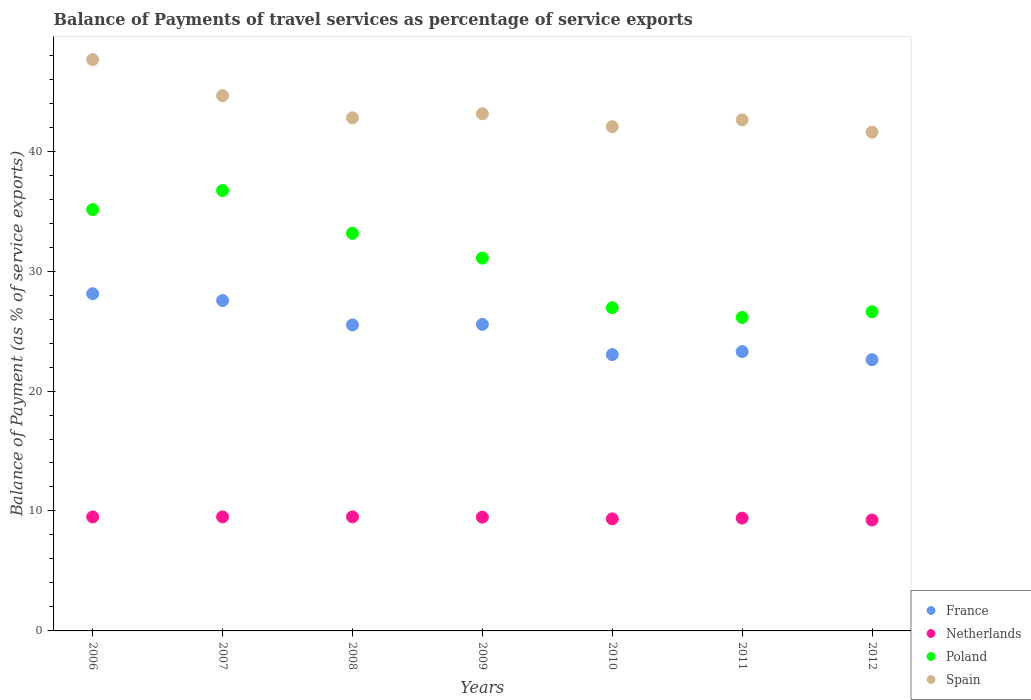How many different coloured dotlines are there?
Keep it short and to the point. 4. Is the number of dotlines equal to the number of legend labels?
Offer a terse response. Yes. What is the balance of payments of travel services in Poland in 2008?
Keep it short and to the point. 33.15. Across all years, what is the maximum balance of payments of travel services in Spain?
Offer a very short reply. 47.63. Across all years, what is the minimum balance of payments of travel services in Spain?
Give a very brief answer. 41.58. In which year was the balance of payments of travel services in Netherlands minimum?
Keep it short and to the point. 2012. What is the total balance of payments of travel services in France in the graph?
Provide a short and direct response. 175.66. What is the difference between the balance of payments of travel services in France in 2009 and that in 2012?
Your answer should be compact. 2.94. What is the difference between the balance of payments of travel services in Poland in 2011 and the balance of payments of travel services in Spain in 2007?
Offer a very short reply. -18.49. What is the average balance of payments of travel services in France per year?
Offer a very short reply. 25.09. In the year 2007, what is the difference between the balance of payments of travel services in Poland and balance of payments of travel services in Netherlands?
Your response must be concise. 27.21. In how many years, is the balance of payments of travel services in Spain greater than 28 %?
Keep it short and to the point. 7. What is the ratio of the balance of payments of travel services in Spain in 2009 to that in 2012?
Provide a short and direct response. 1.04. Is the balance of payments of travel services in France in 2009 less than that in 2012?
Make the answer very short. No. What is the difference between the highest and the second highest balance of payments of travel services in Spain?
Give a very brief answer. 3.01. What is the difference between the highest and the lowest balance of payments of travel services in France?
Your response must be concise. 5.5. Is it the case that in every year, the sum of the balance of payments of travel services in Poland and balance of payments of travel services in Spain  is greater than the balance of payments of travel services in France?
Provide a succinct answer. Yes. How many years are there in the graph?
Make the answer very short. 7. Are the values on the major ticks of Y-axis written in scientific E-notation?
Provide a short and direct response. No. How many legend labels are there?
Your response must be concise. 4. How are the legend labels stacked?
Keep it short and to the point. Vertical. What is the title of the graph?
Offer a terse response. Balance of Payments of travel services as percentage of service exports. Does "Channel Islands" appear as one of the legend labels in the graph?
Provide a short and direct response. No. What is the label or title of the X-axis?
Offer a very short reply. Years. What is the label or title of the Y-axis?
Make the answer very short. Balance of Payment (as % of service exports). What is the Balance of Payment (as % of service exports) in France in 2006?
Provide a succinct answer. 28.11. What is the Balance of Payment (as % of service exports) in Netherlands in 2006?
Ensure brevity in your answer.  9.5. What is the Balance of Payment (as % of service exports) of Poland in 2006?
Your answer should be compact. 35.13. What is the Balance of Payment (as % of service exports) of Spain in 2006?
Your answer should be very brief. 47.63. What is the Balance of Payment (as % of service exports) of France in 2007?
Offer a very short reply. 27.54. What is the Balance of Payment (as % of service exports) of Netherlands in 2007?
Ensure brevity in your answer.  9.51. What is the Balance of Payment (as % of service exports) of Poland in 2007?
Provide a succinct answer. 36.72. What is the Balance of Payment (as % of service exports) in Spain in 2007?
Provide a succinct answer. 44.62. What is the Balance of Payment (as % of service exports) of France in 2008?
Your response must be concise. 25.51. What is the Balance of Payment (as % of service exports) of Netherlands in 2008?
Your response must be concise. 9.51. What is the Balance of Payment (as % of service exports) of Poland in 2008?
Provide a short and direct response. 33.15. What is the Balance of Payment (as % of service exports) of Spain in 2008?
Ensure brevity in your answer.  42.78. What is the Balance of Payment (as % of service exports) of France in 2009?
Provide a short and direct response. 25.55. What is the Balance of Payment (as % of service exports) of Netherlands in 2009?
Give a very brief answer. 9.49. What is the Balance of Payment (as % of service exports) in Poland in 2009?
Offer a very short reply. 31.08. What is the Balance of Payment (as % of service exports) in Spain in 2009?
Your response must be concise. 43.11. What is the Balance of Payment (as % of service exports) in France in 2010?
Your response must be concise. 23.04. What is the Balance of Payment (as % of service exports) of Netherlands in 2010?
Offer a terse response. 9.34. What is the Balance of Payment (as % of service exports) in Poland in 2010?
Keep it short and to the point. 26.95. What is the Balance of Payment (as % of service exports) of Spain in 2010?
Your answer should be very brief. 42.04. What is the Balance of Payment (as % of service exports) of France in 2011?
Provide a succinct answer. 23.29. What is the Balance of Payment (as % of service exports) of Netherlands in 2011?
Provide a succinct answer. 9.41. What is the Balance of Payment (as % of service exports) in Poland in 2011?
Your answer should be compact. 26.13. What is the Balance of Payment (as % of service exports) of Spain in 2011?
Offer a terse response. 42.6. What is the Balance of Payment (as % of service exports) of France in 2012?
Provide a succinct answer. 22.61. What is the Balance of Payment (as % of service exports) in Netherlands in 2012?
Your answer should be very brief. 9.25. What is the Balance of Payment (as % of service exports) of Poland in 2012?
Provide a succinct answer. 26.6. What is the Balance of Payment (as % of service exports) of Spain in 2012?
Ensure brevity in your answer.  41.58. Across all years, what is the maximum Balance of Payment (as % of service exports) in France?
Your response must be concise. 28.11. Across all years, what is the maximum Balance of Payment (as % of service exports) in Netherlands?
Keep it short and to the point. 9.51. Across all years, what is the maximum Balance of Payment (as % of service exports) in Poland?
Give a very brief answer. 36.72. Across all years, what is the maximum Balance of Payment (as % of service exports) in Spain?
Provide a succinct answer. 47.63. Across all years, what is the minimum Balance of Payment (as % of service exports) of France?
Make the answer very short. 22.61. Across all years, what is the minimum Balance of Payment (as % of service exports) in Netherlands?
Provide a short and direct response. 9.25. Across all years, what is the minimum Balance of Payment (as % of service exports) in Poland?
Give a very brief answer. 26.13. Across all years, what is the minimum Balance of Payment (as % of service exports) in Spain?
Make the answer very short. 41.58. What is the total Balance of Payment (as % of service exports) in France in the graph?
Provide a succinct answer. 175.66. What is the total Balance of Payment (as % of service exports) of Netherlands in the graph?
Keep it short and to the point. 65.99. What is the total Balance of Payment (as % of service exports) of Poland in the graph?
Keep it short and to the point. 215.76. What is the total Balance of Payment (as % of service exports) of Spain in the graph?
Your answer should be very brief. 304.36. What is the difference between the Balance of Payment (as % of service exports) in France in 2006 and that in 2007?
Give a very brief answer. 0.57. What is the difference between the Balance of Payment (as % of service exports) in Netherlands in 2006 and that in 2007?
Your response must be concise. -0.01. What is the difference between the Balance of Payment (as % of service exports) of Poland in 2006 and that in 2007?
Your answer should be compact. -1.59. What is the difference between the Balance of Payment (as % of service exports) of Spain in 2006 and that in 2007?
Make the answer very short. 3.01. What is the difference between the Balance of Payment (as % of service exports) in France in 2006 and that in 2008?
Your answer should be compact. 2.6. What is the difference between the Balance of Payment (as % of service exports) of Netherlands in 2006 and that in 2008?
Keep it short and to the point. -0.01. What is the difference between the Balance of Payment (as % of service exports) in Poland in 2006 and that in 2008?
Provide a succinct answer. 1.98. What is the difference between the Balance of Payment (as % of service exports) of Spain in 2006 and that in 2008?
Make the answer very short. 4.86. What is the difference between the Balance of Payment (as % of service exports) of France in 2006 and that in 2009?
Provide a succinct answer. 2.56. What is the difference between the Balance of Payment (as % of service exports) in Netherlands in 2006 and that in 2009?
Offer a very short reply. 0.01. What is the difference between the Balance of Payment (as % of service exports) of Poland in 2006 and that in 2009?
Give a very brief answer. 4.04. What is the difference between the Balance of Payment (as % of service exports) of Spain in 2006 and that in 2009?
Ensure brevity in your answer.  4.52. What is the difference between the Balance of Payment (as % of service exports) of France in 2006 and that in 2010?
Your response must be concise. 5.07. What is the difference between the Balance of Payment (as % of service exports) in Netherlands in 2006 and that in 2010?
Your response must be concise. 0.16. What is the difference between the Balance of Payment (as % of service exports) of Poland in 2006 and that in 2010?
Give a very brief answer. 8.18. What is the difference between the Balance of Payment (as % of service exports) of Spain in 2006 and that in 2010?
Provide a short and direct response. 5.59. What is the difference between the Balance of Payment (as % of service exports) of France in 2006 and that in 2011?
Provide a succinct answer. 4.82. What is the difference between the Balance of Payment (as % of service exports) in Netherlands in 2006 and that in 2011?
Your answer should be very brief. 0.09. What is the difference between the Balance of Payment (as % of service exports) of Poland in 2006 and that in 2011?
Ensure brevity in your answer.  8.99. What is the difference between the Balance of Payment (as % of service exports) in Spain in 2006 and that in 2011?
Give a very brief answer. 5.03. What is the difference between the Balance of Payment (as % of service exports) in France in 2006 and that in 2012?
Your response must be concise. 5.5. What is the difference between the Balance of Payment (as % of service exports) in Netherlands in 2006 and that in 2012?
Provide a short and direct response. 0.25. What is the difference between the Balance of Payment (as % of service exports) of Poland in 2006 and that in 2012?
Give a very brief answer. 8.52. What is the difference between the Balance of Payment (as % of service exports) of Spain in 2006 and that in 2012?
Keep it short and to the point. 6.05. What is the difference between the Balance of Payment (as % of service exports) of France in 2007 and that in 2008?
Offer a very short reply. 2.03. What is the difference between the Balance of Payment (as % of service exports) in Netherlands in 2007 and that in 2008?
Give a very brief answer. -0. What is the difference between the Balance of Payment (as % of service exports) in Poland in 2007 and that in 2008?
Provide a short and direct response. 3.57. What is the difference between the Balance of Payment (as % of service exports) in Spain in 2007 and that in 2008?
Give a very brief answer. 1.85. What is the difference between the Balance of Payment (as % of service exports) in France in 2007 and that in 2009?
Give a very brief answer. 1.99. What is the difference between the Balance of Payment (as % of service exports) in Netherlands in 2007 and that in 2009?
Provide a short and direct response. 0.02. What is the difference between the Balance of Payment (as % of service exports) of Poland in 2007 and that in 2009?
Your answer should be compact. 5.63. What is the difference between the Balance of Payment (as % of service exports) of Spain in 2007 and that in 2009?
Ensure brevity in your answer.  1.51. What is the difference between the Balance of Payment (as % of service exports) of France in 2007 and that in 2010?
Keep it short and to the point. 4.51. What is the difference between the Balance of Payment (as % of service exports) of Netherlands in 2007 and that in 2010?
Ensure brevity in your answer.  0.17. What is the difference between the Balance of Payment (as % of service exports) of Poland in 2007 and that in 2010?
Keep it short and to the point. 9.77. What is the difference between the Balance of Payment (as % of service exports) in Spain in 2007 and that in 2010?
Your answer should be compact. 2.59. What is the difference between the Balance of Payment (as % of service exports) of France in 2007 and that in 2011?
Provide a short and direct response. 4.26. What is the difference between the Balance of Payment (as % of service exports) in Netherlands in 2007 and that in 2011?
Your response must be concise. 0.1. What is the difference between the Balance of Payment (as % of service exports) of Poland in 2007 and that in 2011?
Offer a terse response. 10.58. What is the difference between the Balance of Payment (as % of service exports) of Spain in 2007 and that in 2011?
Keep it short and to the point. 2.02. What is the difference between the Balance of Payment (as % of service exports) in France in 2007 and that in 2012?
Keep it short and to the point. 4.93. What is the difference between the Balance of Payment (as % of service exports) in Netherlands in 2007 and that in 2012?
Your response must be concise. 0.26. What is the difference between the Balance of Payment (as % of service exports) in Poland in 2007 and that in 2012?
Provide a short and direct response. 10.11. What is the difference between the Balance of Payment (as % of service exports) of Spain in 2007 and that in 2012?
Make the answer very short. 3.04. What is the difference between the Balance of Payment (as % of service exports) in France in 2008 and that in 2009?
Your answer should be compact. -0.04. What is the difference between the Balance of Payment (as % of service exports) in Netherlands in 2008 and that in 2009?
Ensure brevity in your answer.  0.02. What is the difference between the Balance of Payment (as % of service exports) of Poland in 2008 and that in 2009?
Your answer should be compact. 2.07. What is the difference between the Balance of Payment (as % of service exports) of Spain in 2008 and that in 2009?
Your answer should be compact. -0.34. What is the difference between the Balance of Payment (as % of service exports) of France in 2008 and that in 2010?
Your response must be concise. 2.48. What is the difference between the Balance of Payment (as % of service exports) of Netherlands in 2008 and that in 2010?
Your response must be concise. 0.17. What is the difference between the Balance of Payment (as % of service exports) in Poland in 2008 and that in 2010?
Keep it short and to the point. 6.2. What is the difference between the Balance of Payment (as % of service exports) of Spain in 2008 and that in 2010?
Offer a terse response. 0.74. What is the difference between the Balance of Payment (as % of service exports) in France in 2008 and that in 2011?
Offer a terse response. 2.23. What is the difference between the Balance of Payment (as % of service exports) in Netherlands in 2008 and that in 2011?
Offer a terse response. 0.1. What is the difference between the Balance of Payment (as % of service exports) in Poland in 2008 and that in 2011?
Your response must be concise. 7.01. What is the difference between the Balance of Payment (as % of service exports) of Spain in 2008 and that in 2011?
Provide a succinct answer. 0.17. What is the difference between the Balance of Payment (as % of service exports) of France in 2008 and that in 2012?
Give a very brief answer. 2.9. What is the difference between the Balance of Payment (as % of service exports) in Netherlands in 2008 and that in 2012?
Provide a succinct answer. 0.26. What is the difference between the Balance of Payment (as % of service exports) of Poland in 2008 and that in 2012?
Provide a short and direct response. 6.54. What is the difference between the Balance of Payment (as % of service exports) of Spain in 2008 and that in 2012?
Ensure brevity in your answer.  1.2. What is the difference between the Balance of Payment (as % of service exports) of France in 2009 and that in 2010?
Give a very brief answer. 2.52. What is the difference between the Balance of Payment (as % of service exports) of Netherlands in 2009 and that in 2010?
Keep it short and to the point. 0.14. What is the difference between the Balance of Payment (as % of service exports) in Poland in 2009 and that in 2010?
Make the answer very short. 4.14. What is the difference between the Balance of Payment (as % of service exports) of Spain in 2009 and that in 2010?
Your answer should be very brief. 1.08. What is the difference between the Balance of Payment (as % of service exports) in France in 2009 and that in 2011?
Your answer should be compact. 2.27. What is the difference between the Balance of Payment (as % of service exports) in Netherlands in 2009 and that in 2011?
Keep it short and to the point. 0.08. What is the difference between the Balance of Payment (as % of service exports) in Poland in 2009 and that in 2011?
Ensure brevity in your answer.  4.95. What is the difference between the Balance of Payment (as % of service exports) in Spain in 2009 and that in 2011?
Make the answer very short. 0.51. What is the difference between the Balance of Payment (as % of service exports) in France in 2009 and that in 2012?
Offer a terse response. 2.94. What is the difference between the Balance of Payment (as % of service exports) in Netherlands in 2009 and that in 2012?
Your answer should be very brief. 0.24. What is the difference between the Balance of Payment (as % of service exports) in Poland in 2009 and that in 2012?
Give a very brief answer. 4.48. What is the difference between the Balance of Payment (as % of service exports) of Spain in 2009 and that in 2012?
Ensure brevity in your answer.  1.53. What is the difference between the Balance of Payment (as % of service exports) in Netherlands in 2010 and that in 2011?
Ensure brevity in your answer.  -0.06. What is the difference between the Balance of Payment (as % of service exports) in Poland in 2010 and that in 2011?
Ensure brevity in your answer.  0.81. What is the difference between the Balance of Payment (as % of service exports) of Spain in 2010 and that in 2011?
Your response must be concise. -0.57. What is the difference between the Balance of Payment (as % of service exports) of France in 2010 and that in 2012?
Provide a succinct answer. 0.42. What is the difference between the Balance of Payment (as % of service exports) in Netherlands in 2010 and that in 2012?
Offer a terse response. 0.1. What is the difference between the Balance of Payment (as % of service exports) of Poland in 2010 and that in 2012?
Keep it short and to the point. 0.34. What is the difference between the Balance of Payment (as % of service exports) of Spain in 2010 and that in 2012?
Your answer should be compact. 0.46. What is the difference between the Balance of Payment (as % of service exports) of France in 2011 and that in 2012?
Your response must be concise. 0.67. What is the difference between the Balance of Payment (as % of service exports) of Netherlands in 2011 and that in 2012?
Your answer should be very brief. 0.16. What is the difference between the Balance of Payment (as % of service exports) in Poland in 2011 and that in 2012?
Make the answer very short. -0.47. What is the difference between the Balance of Payment (as % of service exports) of Spain in 2011 and that in 2012?
Your answer should be very brief. 1.02. What is the difference between the Balance of Payment (as % of service exports) in France in 2006 and the Balance of Payment (as % of service exports) in Netherlands in 2007?
Offer a very short reply. 18.6. What is the difference between the Balance of Payment (as % of service exports) in France in 2006 and the Balance of Payment (as % of service exports) in Poland in 2007?
Ensure brevity in your answer.  -8.6. What is the difference between the Balance of Payment (as % of service exports) of France in 2006 and the Balance of Payment (as % of service exports) of Spain in 2007?
Give a very brief answer. -16.51. What is the difference between the Balance of Payment (as % of service exports) of Netherlands in 2006 and the Balance of Payment (as % of service exports) of Poland in 2007?
Offer a terse response. -27.22. What is the difference between the Balance of Payment (as % of service exports) in Netherlands in 2006 and the Balance of Payment (as % of service exports) in Spain in 2007?
Your answer should be very brief. -35.12. What is the difference between the Balance of Payment (as % of service exports) in Poland in 2006 and the Balance of Payment (as % of service exports) in Spain in 2007?
Make the answer very short. -9.5. What is the difference between the Balance of Payment (as % of service exports) in France in 2006 and the Balance of Payment (as % of service exports) in Netherlands in 2008?
Provide a short and direct response. 18.6. What is the difference between the Balance of Payment (as % of service exports) of France in 2006 and the Balance of Payment (as % of service exports) of Poland in 2008?
Your answer should be compact. -5.04. What is the difference between the Balance of Payment (as % of service exports) of France in 2006 and the Balance of Payment (as % of service exports) of Spain in 2008?
Your answer should be compact. -14.66. What is the difference between the Balance of Payment (as % of service exports) of Netherlands in 2006 and the Balance of Payment (as % of service exports) of Poland in 2008?
Your answer should be compact. -23.65. What is the difference between the Balance of Payment (as % of service exports) of Netherlands in 2006 and the Balance of Payment (as % of service exports) of Spain in 2008?
Ensure brevity in your answer.  -33.28. What is the difference between the Balance of Payment (as % of service exports) of Poland in 2006 and the Balance of Payment (as % of service exports) of Spain in 2008?
Make the answer very short. -7.65. What is the difference between the Balance of Payment (as % of service exports) of France in 2006 and the Balance of Payment (as % of service exports) of Netherlands in 2009?
Offer a terse response. 18.63. What is the difference between the Balance of Payment (as % of service exports) of France in 2006 and the Balance of Payment (as % of service exports) of Poland in 2009?
Offer a very short reply. -2.97. What is the difference between the Balance of Payment (as % of service exports) in France in 2006 and the Balance of Payment (as % of service exports) in Spain in 2009?
Ensure brevity in your answer.  -15. What is the difference between the Balance of Payment (as % of service exports) in Netherlands in 2006 and the Balance of Payment (as % of service exports) in Poland in 2009?
Your answer should be very brief. -21.58. What is the difference between the Balance of Payment (as % of service exports) in Netherlands in 2006 and the Balance of Payment (as % of service exports) in Spain in 2009?
Your response must be concise. -33.61. What is the difference between the Balance of Payment (as % of service exports) of Poland in 2006 and the Balance of Payment (as % of service exports) of Spain in 2009?
Keep it short and to the point. -7.99. What is the difference between the Balance of Payment (as % of service exports) in France in 2006 and the Balance of Payment (as % of service exports) in Netherlands in 2010?
Keep it short and to the point. 18.77. What is the difference between the Balance of Payment (as % of service exports) in France in 2006 and the Balance of Payment (as % of service exports) in Poland in 2010?
Provide a short and direct response. 1.17. What is the difference between the Balance of Payment (as % of service exports) of France in 2006 and the Balance of Payment (as % of service exports) of Spain in 2010?
Provide a short and direct response. -13.93. What is the difference between the Balance of Payment (as % of service exports) of Netherlands in 2006 and the Balance of Payment (as % of service exports) of Poland in 2010?
Keep it short and to the point. -17.45. What is the difference between the Balance of Payment (as % of service exports) of Netherlands in 2006 and the Balance of Payment (as % of service exports) of Spain in 2010?
Provide a succinct answer. -32.54. What is the difference between the Balance of Payment (as % of service exports) of Poland in 2006 and the Balance of Payment (as % of service exports) of Spain in 2010?
Offer a terse response. -6.91. What is the difference between the Balance of Payment (as % of service exports) of France in 2006 and the Balance of Payment (as % of service exports) of Netherlands in 2011?
Your response must be concise. 18.71. What is the difference between the Balance of Payment (as % of service exports) of France in 2006 and the Balance of Payment (as % of service exports) of Poland in 2011?
Make the answer very short. 1.98. What is the difference between the Balance of Payment (as % of service exports) in France in 2006 and the Balance of Payment (as % of service exports) in Spain in 2011?
Offer a terse response. -14.49. What is the difference between the Balance of Payment (as % of service exports) of Netherlands in 2006 and the Balance of Payment (as % of service exports) of Poland in 2011?
Your answer should be very brief. -16.63. What is the difference between the Balance of Payment (as % of service exports) of Netherlands in 2006 and the Balance of Payment (as % of service exports) of Spain in 2011?
Your answer should be compact. -33.1. What is the difference between the Balance of Payment (as % of service exports) of Poland in 2006 and the Balance of Payment (as % of service exports) of Spain in 2011?
Make the answer very short. -7.48. What is the difference between the Balance of Payment (as % of service exports) of France in 2006 and the Balance of Payment (as % of service exports) of Netherlands in 2012?
Your answer should be compact. 18.86. What is the difference between the Balance of Payment (as % of service exports) in France in 2006 and the Balance of Payment (as % of service exports) in Poland in 2012?
Ensure brevity in your answer.  1.51. What is the difference between the Balance of Payment (as % of service exports) in France in 2006 and the Balance of Payment (as % of service exports) in Spain in 2012?
Offer a terse response. -13.47. What is the difference between the Balance of Payment (as % of service exports) of Netherlands in 2006 and the Balance of Payment (as % of service exports) of Poland in 2012?
Keep it short and to the point. -17.1. What is the difference between the Balance of Payment (as % of service exports) of Netherlands in 2006 and the Balance of Payment (as % of service exports) of Spain in 2012?
Your response must be concise. -32.08. What is the difference between the Balance of Payment (as % of service exports) in Poland in 2006 and the Balance of Payment (as % of service exports) in Spain in 2012?
Give a very brief answer. -6.46. What is the difference between the Balance of Payment (as % of service exports) in France in 2007 and the Balance of Payment (as % of service exports) in Netherlands in 2008?
Ensure brevity in your answer.  18.03. What is the difference between the Balance of Payment (as % of service exports) of France in 2007 and the Balance of Payment (as % of service exports) of Poland in 2008?
Your answer should be very brief. -5.61. What is the difference between the Balance of Payment (as % of service exports) in France in 2007 and the Balance of Payment (as % of service exports) in Spain in 2008?
Ensure brevity in your answer.  -15.23. What is the difference between the Balance of Payment (as % of service exports) in Netherlands in 2007 and the Balance of Payment (as % of service exports) in Poland in 2008?
Provide a succinct answer. -23.64. What is the difference between the Balance of Payment (as % of service exports) of Netherlands in 2007 and the Balance of Payment (as % of service exports) of Spain in 2008?
Your answer should be very brief. -33.27. What is the difference between the Balance of Payment (as % of service exports) of Poland in 2007 and the Balance of Payment (as % of service exports) of Spain in 2008?
Provide a succinct answer. -6.06. What is the difference between the Balance of Payment (as % of service exports) of France in 2007 and the Balance of Payment (as % of service exports) of Netherlands in 2009?
Offer a very short reply. 18.06. What is the difference between the Balance of Payment (as % of service exports) of France in 2007 and the Balance of Payment (as % of service exports) of Poland in 2009?
Offer a very short reply. -3.54. What is the difference between the Balance of Payment (as % of service exports) of France in 2007 and the Balance of Payment (as % of service exports) of Spain in 2009?
Your answer should be very brief. -15.57. What is the difference between the Balance of Payment (as % of service exports) in Netherlands in 2007 and the Balance of Payment (as % of service exports) in Poland in 2009?
Your answer should be very brief. -21.58. What is the difference between the Balance of Payment (as % of service exports) in Netherlands in 2007 and the Balance of Payment (as % of service exports) in Spain in 2009?
Offer a very short reply. -33.61. What is the difference between the Balance of Payment (as % of service exports) in Poland in 2007 and the Balance of Payment (as % of service exports) in Spain in 2009?
Offer a very short reply. -6.4. What is the difference between the Balance of Payment (as % of service exports) of France in 2007 and the Balance of Payment (as % of service exports) of Netherlands in 2010?
Your response must be concise. 18.2. What is the difference between the Balance of Payment (as % of service exports) of France in 2007 and the Balance of Payment (as % of service exports) of Poland in 2010?
Provide a short and direct response. 0.6. What is the difference between the Balance of Payment (as % of service exports) in France in 2007 and the Balance of Payment (as % of service exports) in Spain in 2010?
Provide a succinct answer. -14.49. What is the difference between the Balance of Payment (as % of service exports) of Netherlands in 2007 and the Balance of Payment (as % of service exports) of Poland in 2010?
Keep it short and to the point. -17.44. What is the difference between the Balance of Payment (as % of service exports) of Netherlands in 2007 and the Balance of Payment (as % of service exports) of Spain in 2010?
Make the answer very short. -32.53. What is the difference between the Balance of Payment (as % of service exports) of Poland in 2007 and the Balance of Payment (as % of service exports) of Spain in 2010?
Provide a succinct answer. -5.32. What is the difference between the Balance of Payment (as % of service exports) of France in 2007 and the Balance of Payment (as % of service exports) of Netherlands in 2011?
Keep it short and to the point. 18.14. What is the difference between the Balance of Payment (as % of service exports) in France in 2007 and the Balance of Payment (as % of service exports) in Poland in 2011?
Offer a terse response. 1.41. What is the difference between the Balance of Payment (as % of service exports) in France in 2007 and the Balance of Payment (as % of service exports) in Spain in 2011?
Make the answer very short. -15.06. What is the difference between the Balance of Payment (as % of service exports) in Netherlands in 2007 and the Balance of Payment (as % of service exports) in Poland in 2011?
Provide a succinct answer. -16.63. What is the difference between the Balance of Payment (as % of service exports) in Netherlands in 2007 and the Balance of Payment (as % of service exports) in Spain in 2011?
Offer a very short reply. -33.1. What is the difference between the Balance of Payment (as % of service exports) of Poland in 2007 and the Balance of Payment (as % of service exports) of Spain in 2011?
Your answer should be compact. -5.89. What is the difference between the Balance of Payment (as % of service exports) of France in 2007 and the Balance of Payment (as % of service exports) of Netherlands in 2012?
Keep it short and to the point. 18.3. What is the difference between the Balance of Payment (as % of service exports) in France in 2007 and the Balance of Payment (as % of service exports) in Poland in 2012?
Give a very brief answer. 0.94. What is the difference between the Balance of Payment (as % of service exports) of France in 2007 and the Balance of Payment (as % of service exports) of Spain in 2012?
Provide a short and direct response. -14.04. What is the difference between the Balance of Payment (as % of service exports) in Netherlands in 2007 and the Balance of Payment (as % of service exports) in Poland in 2012?
Make the answer very short. -17.1. What is the difference between the Balance of Payment (as % of service exports) in Netherlands in 2007 and the Balance of Payment (as % of service exports) in Spain in 2012?
Your answer should be very brief. -32.07. What is the difference between the Balance of Payment (as % of service exports) in Poland in 2007 and the Balance of Payment (as % of service exports) in Spain in 2012?
Offer a terse response. -4.87. What is the difference between the Balance of Payment (as % of service exports) of France in 2008 and the Balance of Payment (as % of service exports) of Netherlands in 2009?
Offer a very short reply. 16.03. What is the difference between the Balance of Payment (as % of service exports) of France in 2008 and the Balance of Payment (as % of service exports) of Poland in 2009?
Your answer should be compact. -5.57. What is the difference between the Balance of Payment (as % of service exports) of France in 2008 and the Balance of Payment (as % of service exports) of Spain in 2009?
Offer a terse response. -17.6. What is the difference between the Balance of Payment (as % of service exports) in Netherlands in 2008 and the Balance of Payment (as % of service exports) in Poland in 2009?
Keep it short and to the point. -21.57. What is the difference between the Balance of Payment (as % of service exports) in Netherlands in 2008 and the Balance of Payment (as % of service exports) in Spain in 2009?
Offer a very short reply. -33.6. What is the difference between the Balance of Payment (as % of service exports) in Poland in 2008 and the Balance of Payment (as % of service exports) in Spain in 2009?
Your answer should be compact. -9.96. What is the difference between the Balance of Payment (as % of service exports) of France in 2008 and the Balance of Payment (as % of service exports) of Netherlands in 2010?
Provide a succinct answer. 16.17. What is the difference between the Balance of Payment (as % of service exports) of France in 2008 and the Balance of Payment (as % of service exports) of Poland in 2010?
Provide a succinct answer. -1.43. What is the difference between the Balance of Payment (as % of service exports) in France in 2008 and the Balance of Payment (as % of service exports) in Spain in 2010?
Offer a very short reply. -16.52. What is the difference between the Balance of Payment (as % of service exports) in Netherlands in 2008 and the Balance of Payment (as % of service exports) in Poland in 2010?
Give a very brief answer. -17.44. What is the difference between the Balance of Payment (as % of service exports) of Netherlands in 2008 and the Balance of Payment (as % of service exports) of Spain in 2010?
Give a very brief answer. -32.53. What is the difference between the Balance of Payment (as % of service exports) in Poland in 2008 and the Balance of Payment (as % of service exports) in Spain in 2010?
Offer a terse response. -8.89. What is the difference between the Balance of Payment (as % of service exports) of France in 2008 and the Balance of Payment (as % of service exports) of Netherlands in 2011?
Make the answer very short. 16.11. What is the difference between the Balance of Payment (as % of service exports) of France in 2008 and the Balance of Payment (as % of service exports) of Poland in 2011?
Offer a terse response. -0.62. What is the difference between the Balance of Payment (as % of service exports) of France in 2008 and the Balance of Payment (as % of service exports) of Spain in 2011?
Your response must be concise. -17.09. What is the difference between the Balance of Payment (as % of service exports) of Netherlands in 2008 and the Balance of Payment (as % of service exports) of Poland in 2011?
Make the answer very short. -16.63. What is the difference between the Balance of Payment (as % of service exports) of Netherlands in 2008 and the Balance of Payment (as % of service exports) of Spain in 2011?
Offer a terse response. -33.09. What is the difference between the Balance of Payment (as % of service exports) of Poland in 2008 and the Balance of Payment (as % of service exports) of Spain in 2011?
Offer a terse response. -9.45. What is the difference between the Balance of Payment (as % of service exports) in France in 2008 and the Balance of Payment (as % of service exports) in Netherlands in 2012?
Ensure brevity in your answer.  16.27. What is the difference between the Balance of Payment (as % of service exports) of France in 2008 and the Balance of Payment (as % of service exports) of Poland in 2012?
Provide a short and direct response. -1.09. What is the difference between the Balance of Payment (as % of service exports) in France in 2008 and the Balance of Payment (as % of service exports) in Spain in 2012?
Offer a very short reply. -16.07. What is the difference between the Balance of Payment (as % of service exports) in Netherlands in 2008 and the Balance of Payment (as % of service exports) in Poland in 2012?
Provide a succinct answer. -17.1. What is the difference between the Balance of Payment (as % of service exports) of Netherlands in 2008 and the Balance of Payment (as % of service exports) of Spain in 2012?
Offer a terse response. -32.07. What is the difference between the Balance of Payment (as % of service exports) in Poland in 2008 and the Balance of Payment (as % of service exports) in Spain in 2012?
Provide a succinct answer. -8.43. What is the difference between the Balance of Payment (as % of service exports) of France in 2009 and the Balance of Payment (as % of service exports) of Netherlands in 2010?
Your response must be concise. 16.21. What is the difference between the Balance of Payment (as % of service exports) in France in 2009 and the Balance of Payment (as % of service exports) in Poland in 2010?
Ensure brevity in your answer.  -1.39. What is the difference between the Balance of Payment (as % of service exports) of France in 2009 and the Balance of Payment (as % of service exports) of Spain in 2010?
Provide a short and direct response. -16.48. What is the difference between the Balance of Payment (as % of service exports) of Netherlands in 2009 and the Balance of Payment (as % of service exports) of Poland in 2010?
Ensure brevity in your answer.  -17.46. What is the difference between the Balance of Payment (as % of service exports) of Netherlands in 2009 and the Balance of Payment (as % of service exports) of Spain in 2010?
Offer a terse response. -32.55. What is the difference between the Balance of Payment (as % of service exports) in Poland in 2009 and the Balance of Payment (as % of service exports) in Spain in 2010?
Make the answer very short. -10.95. What is the difference between the Balance of Payment (as % of service exports) of France in 2009 and the Balance of Payment (as % of service exports) of Netherlands in 2011?
Keep it short and to the point. 16.15. What is the difference between the Balance of Payment (as % of service exports) in France in 2009 and the Balance of Payment (as % of service exports) in Poland in 2011?
Offer a very short reply. -0.58. What is the difference between the Balance of Payment (as % of service exports) in France in 2009 and the Balance of Payment (as % of service exports) in Spain in 2011?
Your answer should be compact. -17.05. What is the difference between the Balance of Payment (as % of service exports) in Netherlands in 2009 and the Balance of Payment (as % of service exports) in Poland in 2011?
Offer a terse response. -16.65. What is the difference between the Balance of Payment (as % of service exports) of Netherlands in 2009 and the Balance of Payment (as % of service exports) of Spain in 2011?
Offer a very short reply. -33.12. What is the difference between the Balance of Payment (as % of service exports) in Poland in 2009 and the Balance of Payment (as % of service exports) in Spain in 2011?
Provide a succinct answer. -11.52. What is the difference between the Balance of Payment (as % of service exports) in France in 2009 and the Balance of Payment (as % of service exports) in Netherlands in 2012?
Give a very brief answer. 16.31. What is the difference between the Balance of Payment (as % of service exports) in France in 2009 and the Balance of Payment (as % of service exports) in Poland in 2012?
Ensure brevity in your answer.  -1.05. What is the difference between the Balance of Payment (as % of service exports) in France in 2009 and the Balance of Payment (as % of service exports) in Spain in 2012?
Ensure brevity in your answer.  -16.03. What is the difference between the Balance of Payment (as % of service exports) in Netherlands in 2009 and the Balance of Payment (as % of service exports) in Poland in 2012?
Offer a terse response. -17.12. What is the difference between the Balance of Payment (as % of service exports) in Netherlands in 2009 and the Balance of Payment (as % of service exports) in Spain in 2012?
Ensure brevity in your answer.  -32.1. What is the difference between the Balance of Payment (as % of service exports) of Poland in 2009 and the Balance of Payment (as % of service exports) of Spain in 2012?
Your response must be concise. -10.5. What is the difference between the Balance of Payment (as % of service exports) of France in 2010 and the Balance of Payment (as % of service exports) of Netherlands in 2011?
Make the answer very short. 13.63. What is the difference between the Balance of Payment (as % of service exports) in France in 2010 and the Balance of Payment (as % of service exports) in Poland in 2011?
Ensure brevity in your answer.  -3.1. What is the difference between the Balance of Payment (as % of service exports) of France in 2010 and the Balance of Payment (as % of service exports) of Spain in 2011?
Ensure brevity in your answer.  -19.57. What is the difference between the Balance of Payment (as % of service exports) in Netherlands in 2010 and the Balance of Payment (as % of service exports) in Poland in 2011?
Your answer should be compact. -16.79. What is the difference between the Balance of Payment (as % of service exports) of Netherlands in 2010 and the Balance of Payment (as % of service exports) of Spain in 2011?
Ensure brevity in your answer.  -33.26. What is the difference between the Balance of Payment (as % of service exports) in Poland in 2010 and the Balance of Payment (as % of service exports) in Spain in 2011?
Your response must be concise. -15.66. What is the difference between the Balance of Payment (as % of service exports) in France in 2010 and the Balance of Payment (as % of service exports) in Netherlands in 2012?
Offer a terse response. 13.79. What is the difference between the Balance of Payment (as % of service exports) of France in 2010 and the Balance of Payment (as % of service exports) of Poland in 2012?
Your response must be concise. -3.57. What is the difference between the Balance of Payment (as % of service exports) in France in 2010 and the Balance of Payment (as % of service exports) in Spain in 2012?
Provide a succinct answer. -18.54. What is the difference between the Balance of Payment (as % of service exports) in Netherlands in 2010 and the Balance of Payment (as % of service exports) in Poland in 2012?
Your answer should be very brief. -17.26. What is the difference between the Balance of Payment (as % of service exports) in Netherlands in 2010 and the Balance of Payment (as % of service exports) in Spain in 2012?
Your response must be concise. -32.24. What is the difference between the Balance of Payment (as % of service exports) of Poland in 2010 and the Balance of Payment (as % of service exports) of Spain in 2012?
Give a very brief answer. -14.63. What is the difference between the Balance of Payment (as % of service exports) of France in 2011 and the Balance of Payment (as % of service exports) of Netherlands in 2012?
Offer a terse response. 14.04. What is the difference between the Balance of Payment (as % of service exports) of France in 2011 and the Balance of Payment (as % of service exports) of Poland in 2012?
Your answer should be very brief. -3.32. What is the difference between the Balance of Payment (as % of service exports) in France in 2011 and the Balance of Payment (as % of service exports) in Spain in 2012?
Provide a succinct answer. -18.29. What is the difference between the Balance of Payment (as % of service exports) in Netherlands in 2011 and the Balance of Payment (as % of service exports) in Poland in 2012?
Ensure brevity in your answer.  -17.2. What is the difference between the Balance of Payment (as % of service exports) in Netherlands in 2011 and the Balance of Payment (as % of service exports) in Spain in 2012?
Your answer should be very brief. -32.18. What is the difference between the Balance of Payment (as % of service exports) of Poland in 2011 and the Balance of Payment (as % of service exports) of Spain in 2012?
Offer a terse response. -15.45. What is the average Balance of Payment (as % of service exports) in France per year?
Ensure brevity in your answer.  25.09. What is the average Balance of Payment (as % of service exports) in Netherlands per year?
Your answer should be compact. 9.43. What is the average Balance of Payment (as % of service exports) in Poland per year?
Keep it short and to the point. 30.82. What is the average Balance of Payment (as % of service exports) of Spain per year?
Give a very brief answer. 43.48. In the year 2006, what is the difference between the Balance of Payment (as % of service exports) of France and Balance of Payment (as % of service exports) of Netherlands?
Your answer should be compact. 18.61. In the year 2006, what is the difference between the Balance of Payment (as % of service exports) of France and Balance of Payment (as % of service exports) of Poland?
Your answer should be compact. -7.01. In the year 2006, what is the difference between the Balance of Payment (as % of service exports) in France and Balance of Payment (as % of service exports) in Spain?
Your answer should be compact. -19.52. In the year 2006, what is the difference between the Balance of Payment (as % of service exports) of Netherlands and Balance of Payment (as % of service exports) of Poland?
Make the answer very short. -25.63. In the year 2006, what is the difference between the Balance of Payment (as % of service exports) in Netherlands and Balance of Payment (as % of service exports) in Spain?
Your response must be concise. -38.13. In the year 2006, what is the difference between the Balance of Payment (as % of service exports) of Poland and Balance of Payment (as % of service exports) of Spain?
Ensure brevity in your answer.  -12.51. In the year 2007, what is the difference between the Balance of Payment (as % of service exports) of France and Balance of Payment (as % of service exports) of Netherlands?
Your answer should be compact. 18.04. In the year 2007, what is the difference between the Balance of Payment (as % of service exports) in France and Balance of Payment (as % of service exports) in Poland?
Offer a very short reply. -9.17. In the year 2007, what is the difference between the Balance of Payment (as % of service exports) of France and Balance of Payment (as % of service exports) of Spain?
Your answer should be very brief. -17.08. In the year 2007, what is the difference between the Balance of Payment (as % of service exports) in Netherlands and Balance of Payment (as % of service exports) in Poland?
Your response must be concise. -27.21. In the year 2007, what is the difference between the Balance of Payment (as % of service exports) of Netherlands and Balance of Payment (as % of service exports) of Spain?
Give a very brief answer. -35.12. In the year 2007, what is the difference between the Balance of Payment (as % of service exports) of Poland and Balance of Payment (as % of service exports) of Spain?
Offer a very short reply. -7.91. In the year 2008, what is the difference between the Balance of Payment (as % of service exports) in France and Balance of Payment (as % of service exports) in Netherlands?
Give a very brief answer. 16. In the year 2008, what is the difference between the Balance of Payment (as % of service exports) in France and Balance of Payment (as % of service exports) in Poland?
Ensure brevity in your answer.  -7.64. In the year 2008, what is the difference between the Balance of Payment (as % of service exports) in France and Balance of Payment (as % of service exports) in Spain?
Your answer should be very brief. -17.26. In the year 2008, what is the difference between the Balance of Payment (as % of service exports) in Netherlands and Balance of Payment (as % of service exports) in Poland?
Provide a succinct answer. -23.64. In the year 2008, what is the difference between the Balance of Payment (as % of service exports) of Netherlands and Balance of Payment (as % of service exports) of Spain?
Your response must be concise. -33.27. In the year 2008, what is the difference between the Balance of Payment (as % of service exports) of Poland and Balance of Payment (as % of service exports) of Spain?
Offer a very short reply. -9.63. In the year 2009, what is the difference between the Balance of Payment (as % of service exports) in France and Balance of Payment (as % of service exports) in Netherlands?
Your response must be concise. 16.07. In the year 2009, what is the difference between the Balance of Payment (as % of service exports) of France and Balance of Payment (as % of service exports) of Poland?
Offer a terse response. -5.53. In the year 2009, what is the difference between the Balance of Payment (as % of service exports) in France and Balance of Payment (as % of service exports) in Spain?
Your answer should be compact. -17.56. In the year 2009, what is the difference between the Balance of Payment (as % of service exports) of Netherlands and Balance of Payment (as % of service exports) of Poland?
Offer a very short reply. -21.6. In the year 2009, what is the difference between the Balance of Payment (as % of service exports) of Netherlands and Balance of Payment (as % of service exports) of Spain?
Give a very brief answer. -33.63. In the year 2009, what is the difference between the Balance of Payment (as % of service exports) of Poland and Balance of Payment (as % of service exports) of Spain?
Your response must be concise. -12.03. In the year 2010, what is the difference between the Balance of Payment (as % of service exports) of France and Balance of Payment (as % of service exports) of Netherlands?
Keep it short and to the point. 13.7. In the year 2010, what is the difference between the Balance of Payment (as % of service exports) of France and Balance of Payment (as % of service exports) of Poland?
Provide a succinct answer. -3.91. In the year 2010, what is the difference between the Balance of Payment (as % of service exports) of France and Balance of Payment (as % of service exports) of Spain?
Your answer should be compact. -19. In the year 2010, what is the difference between the Balance of Payment (as % of service exports) in Netherlands and Balance of Payment (as % of service exports) in Poland?
Your answer should be compact. -17.6. In the year 2010, what is the difference between the Balance of Payment (as % of service exports) in Netherlands and Balance of Payment (as % of service exports) in Spain?
Your answer should be very brief. -32.69. In the year 2010, what is the difference between the Balance of Payment (as % of service exports) in Poland and Balance of Payment (as % of service exports) in Spain?
Provide a short and direct response. -15.09. In the year 2011, what is the difference between the Balance of Payment (as % of service exports) in France and Balance of Payment (as % of service exports) in Netherlands?
Your answer should be very brief. 13.88. In the year 2011, what is the difference between the Balance of Payment (as % of service exports) in France and Balance of Payment (as % of service exports) in Poland?
Offer a very short reply. -2.85. In the year 2011, what is the difference between the Balance of Payment (as % of service exports) of France and Balance of Payment (as % of service exports) of Spain?
Provide a short and direct response. -19.32. In the year 2011, what is the difference between the Balance of Payment (as % of service exports) in Netherlands and Balance of Payment (as % of service exports) in Poland?
Your answer should be very brief. -16.73. In the year 2011, what is the difference between the Balance of Payment (as % of service exports) of Netherlands and Balance of Payment (as % of service exports) of Spain?
Keep it short and to the point. -33.2. In the year 2011, what is the difference between the Balance of Payment (as % of service exports) of Poland and Balance of Payment (as % of service exports) of Spain?
Offer a very short reply. -16.47. In the year 2012, what is the difference between the Balance of Payment (as % of service exports) in France and Balance of Payment (as % of service exports) in Netherlands?
Make the answer very short. 13.37. In the year 2012, what is the difference between the Balance of Payment (as % of service exports) of France and Balance of Payment (as % of service exports) of Poland?
Make the answer very short. -3.99. In the year 2012, what is the difference between the Balance of Payment (as % of service exports) in France and Balance of Payment (as % of service exports) in Spain?
Ensure brevity in your answer.  -18.97. In the year 2012, what is the difference between the Balance of Payment (as % of service exports) in Netherlands and Balance of Payment (as % of service exports) in Poland?
Provide a short and direct response. -17.36. In the year 2012, what is the difference between the Balance of Payment (as % of service exports) of Netherlands and Balance of Payment (as % of service exports) of Spain?
Make the answer very short. -32.33. In the year 2012, what is the difference between the Balance of Payment (as % of service exports) of Poland and Balance of Payment (as % of service exports) of Spain?
Provide a succinct answer. -14.98. What is the ratio of the Balance of Payment (as % of service exports) of France in 2006 to that in 2007?
Make the answer very short. 1.02. What is the ratio of the Balance of Payment (as % of service exports) of Poland in 2006 to that in 2007?
Ensure brevity in your answer.  0.96. What is the ratio of the Balance of Payment (as % of service exports) in Spain in 2006 to that in 2007?
Your answer should be very brief. 1.07. What is the ratio of the Balance of Payment (as % of service exports) of France in 2006 to that in 2008?
Ensure brevity in your answer.  1.1. What is the ratio of the Balance of Payment (as % of service exports) of Poland in 2006 to that in 2008?
Your answer should be compact. 1.06. What is the ratio of the Balance of Payment (as % of service exports) in Spain in 2006 to that in 2008?
Offer a terse response. 1.11. What is the ratio of the Balance of Payment (as % of service exports) of France in 2006 to that in 2009?
Your answer should be very brief. 1.1. What is the ratio of the Balance of Payment (as % of service exports) in Netherlands in 2006 to that in 2009?
Your answer should be very brief. 1. What is the ratio of the Balance of Payment (as % of service exports) in Poland in 2006 to that in 2009?
Keep it short and to the point. 1.13. What is the ratio of the Balance of Payment (as % of service exports) of Spain in 2006 to that in 2009?
Your answer should be compact. 1.1. What is the ratio of the Balance of Payment (as % of service exports) of France in 2006 to that in 2010?
Your answer should be very brief. 1.22. What is the ratio of the Balance of Payment (as % of service exports) in Netherlands in 2006 to that in 2010?
Your answer should be very brief. 1.02. What is the ratio of the Balance of Payment (as % of service exports) in Poland in 2006 to that in 2010?
Your answer should be very brief. 1.3. What is the ratio of the Balance of Payment (as % of service exports) in Spain in 2006 to that in 2010?
Offer a terse response. 1.13. What is the ratio of the Balance of Payment (as % of service exports) in France in 2006 to that in 2011?
Offer a terse response. 1.21. What is the ratio of the Balance of Payment (as % of service exports) in Poland in 2006 to that in 2011?
Your response must be concise. 1.34. What is the ratio of the Balance of Payment (as % of service exports) in Spain in 2006 to that in 2011?
Give a very brief answer. 1.12. What is the ratio of the Balance of Payment (as % of service exports) of France in 2006 to that in 2012?
Offer a terse response. 1.24. What is the ratio of the Balance of Payment (as % of service exports) of Netherlands in 2006 to that in 2012?
Offer a very short reply. 1.03. What is the ratio of the Balance of Payment (as % of service exports) of Poland in 2006 to that in 2012?
Your answer should be very brief. 1.32. What is the ratio of the Balance of Payment (as % of service exports) of Spain in 2006 to that in 2012?
Ensure brevity in your answer.  1.15. What is the ratio of the Balance of Payment (as % of service exports) in France in 2007 to that in 2008?
Provide a short and direct response. 1.08. What is the ratio of the Balance of Payment (as % of service exports) of Poland in 2007 to that in 2008?
Your answer should be compact. 1.11. What is the ratio of the Balance of Payment (as % of service exports) in Spain in 2007 to that in 2008?
Keep it short and to the point. 1.04. What is the ratio of the Balance of Payment (as % of service exports) in France in 2007 to that in 2009?
Make the answer very short. 1.08. What is the ratio of the Balance of Payment (as % of service exports) in Poland in 2007 to that in 2009?
Your answer should be very brief. 1.18. What is the ratio of the Balance of Payment (as % of service exports) in Spain in 2007 to that in 2009?
Your answer should be compact. 1.03. What is the ratio of the Balance of Payment (as % of service exports) in France in 2007 to that in 2010?
Offer a terse response. 1.2. What is the ratio of the Balance of Payment (as % of service exports) of Netherlands in 2007 to that in 2010?
Your answer should be very brief. 1.02. What is the ratio of the Balance of Payment (as % of service exports) of Poland in 2007 to that in 2010?
Give a very brief answer. 1.36. What is the ratio of the Balance of Payment (as % of service exports) of Spain in 2007 to that in 2010?
Make the answer very short. 1.06. What is the ratio of the Balance of Payment (as % of service exports) in France in 2007 to that in 2011?
Offer a terse response. 1.18. What is the ratio of the Balance of Payment (as % of service exports) of Netherlands in 2007 to that in 2011?
Keep it short and to the point. 1.01. What is the ratio of the Balance of Payment (as % of service exports) in Poland in 2007 to that in 2011?
Keep it short and to the point. 1.4. What is the ratio of the Balance of Payment (as % of service exports) in Spain in 2007 to that in 2011?
Make the answer very short. 1.05. What is the ratio of the Balance of Payment (as % of service exports) in France in 2007 to that in 2012?
Provide a short and direct response. 1.22. What is the ratio of the Balance of Payment (as % of service exports) in Netherlands in 2007 to that in 2012?
Your answer should be very brief. 1.03. What is the ratio of the Balance of Payment (as % of service exports) in Poland in 2007 to that in 2012?
Your answer should be very brief. 1.38. What is the ratio of the Balance of Payment (as % of service exports) of Spain in 2007 to that in 2012?
Keep it short and to the point. 1.07. What is the ratio of the Balance of Payment (as % of service exports) of France in 2008 to that in 2009?
Keep it short and to the point. 1. What is the ratio of the Balance of Payment (as % of service exports) in Netherlands in 2008 to that in 2009?
Provide a succinct answer. 1. What is the ratio of the Balance of Payment (as % of service exports) in Poland in 2008 to that in 2009?
Provide a succinct answer. 1.07. What is the ratio of the Balance of Payment (as % of service exports) of Spain in 2008 to that in 2009?
Offer a very short reply. 0.99. What is the ratio of the Balance of Payment (as % of service exports) of France in 2008 to that in 2010?
Give a very brief answer. 1.11. What is the ratio of the Balance of Payment (as % of service exports) of Netherlands in 2008 to that in 2010?
Your answer should be compact. 1.02. What is the ratio of the Balance of Payment (as % of service exports) of Poland in 2008 to that in 2010?
Provide a short and direct response. 1.23. What is the ratio of the Balance of Payment (as % of service exports) of Spain in 2008 to that in 2010?
Make the answer very short. 1.02. What is the ratio of the Balance of Payment (as % of service exports) in France in 2008 to that in 2011?
Give a very brief answer. 1.1. What is the ratio of the Balance of Payment (as % of service exports) in Netherlands in 2008 to that in 2011?
Ensure brevity in your answer.  1.01. What is the ratio of the Balance of Payment (as % of service exports) of Poland in 2008 to that in 2011?
Your answer should be compact. 1.27. What is the ratio of the Balance of Payment (as % of service exports) of France in 2008 to that in 2012?
Offer a terse response. 1.13. What is the ratio of the Balance of Payment (as % of service exports) in Netherlands in 2008 to that in 2012?
Offer a very short reply. 1.03. What is the ratio of the Balance of Payment (as % of service exports) in Poland in 2008 to that in 2012?
Ensure brevity in your answer.  1.25. What is the ratio of the Balance of Payment (as % of service exports) of Spain in 2008 to that in 2012?
Give a very brief answer. 1.03. What is the ratio of the Balance of Payment (as % of service exports) in France in 2009 to that in 2010?
Provide a short and direct response. 1.11. What is the ratio of the Balance of Payment (as % of service exports) in Netherlands in 2009 to that in 2010?
Keep it short and to the point. 1.02. What is the ratio of the Balance of Payment (as % of service exports) of Poland in 2009 to that in 2010?
Your answer should be very brief. 1.15. What is the ratio of the Balance of Payment (as % of service exports) in Spain in 2009 to that in 2010?
Offer a very short reply. 1.03. What is the ratio of the Balance of Payment (as % of service exports) in France in 2009 to that in 2011?
Your response must be concise. 1.1. What is the ratio of the Balance of Payment (as % of service exports) in Netherlands in 2009 to that in 2011?
Offer a very short reply. 1.01. What is the ratio of the Balance of Payment (as % of service exports) of Poland in 2009 to that in 2011?
Offer a very short reply. 1.19. What is the ratio of the Balance of Payment (as % of service exports) in Spain in 2009 to that in 2011?
Make the answer very short. 1.01. What is the ratio of the Balance of Payment (as % of service exports) of France in 2009 to that in 2012?
Your answer should be compact. 1.13. What is the ratio of the Balance of Payment (as % of service exports) of Netherlands in 2009 to that in 2012?
Provide a succinct answer. 1.03. What is the ratio of the Balance of Payment (as % of service exports) in Poland in 2009 to that in 2012?
Offer a terse response. 1.17. What is the ratio of the Balance of Payment (as % of service exports) in Spain in 2009 to that in 2012?
Your answer should be very brief. 1.04. What is the ratio of the Balance of Payment (as % of service exports) of France in 2010 to that in 2011?
Provide a succinct answer. 0.99. What is the ratio of the Balance of Payment (as % of service exports) in Poland in 2010 to that in 2011?
Your answer should be very brief. 1.03. What is the ratio of the Balance of Payment (as % of service exports) in Spain in 2010 to that in 2011?
Make the answer very short. 0.99. What is the ratio of the Balance of Payment (as % of service exports) in France in 2010 to that in 2012?
Your answer should be very brief. 1.02. What is the ratio of the Balance of Payment (as % of service exports) of Netherlands in 2010 to that in 2012?
Your response must be concise. 1.01. What is the ratio of the Balance of Payment (as % of service exports) in Poland in 2010 to that in 2012?
Offer a very short reply. 1.01. What is the ratio of the Balance of Payment (as % of service exports) in Spain in 2010 to that in 2012?
Offer a very short reply. 1.01. What is the ratio of the Balance of Payment (as % of service exports) in France in 2011 to that in 2012?
Your answer should be compact. 1.03. What is the ratio of the Balance of Payment (as % of service exports) in Netherlands in 2011 to that in 2012?
Ensure brevity in your answer.  1.02. What is the ratio of the Balance of Payment (as % of service exports) of Poland in 2011 to that in 2012?
Give a very brief answer. 0.98. What is the ratio of the Balance of Payment (as % of service exports) in Spain in 2011 to that in 2012?
Make the answer very short. 1.02. What is the difference between the highest and the second highest Balance of Payment (as % of service exports) in France?
Make the answer very short. 0.57. What is the difference between the highest and the second highest Balance of Payment (as % of service exports) in Netherlands?
Your response must be concise. 0. What is the difference between the highest and the second highest Balance of Payment (as % of service exports) in Poland?
Your answer should be very brief. 1.59. What is the difference between the highest and the second highest Balance of Payment (as % of service exports) of Spain?
Make the answer very short. 3.01. What is the difference between the highest and the lowest Balance of Payment (as % of service exports) of France?
Give a very brief answer. 5.5. What is the difference between the highest and the lowest Balance of Payment (as % of service exports) of Netherlands?
Ensure brevity in your answer.  0.26. What is the difference between the highest and the lowest Balance of Payment (as % of service exports) in Poland?
Provide a short and direct response. 10.58. What is the difference between the highest and the lowest Balance of Payment (as % of service exports) in Spain?
Offer a terse response. 6.05. 